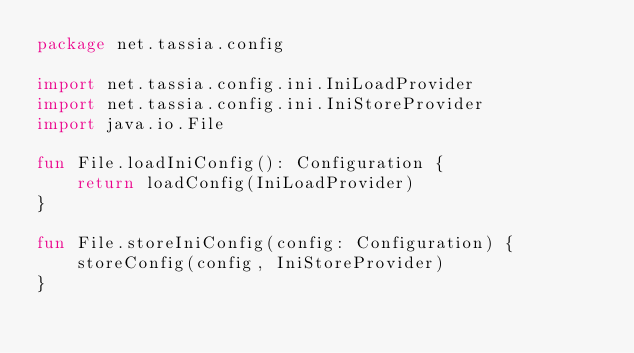<code> <loc_0><loc_0><loc_500><loc_500><_Kotlin_>package net.tassia.config

import net.tassia.config.ini.IniLoadProvider
import net.tassia.config.ini.IniStoreProvider
import java.io.File

fun File.loadIniConfig(): Configuration {
	return loadConfig(IniLoadProvider)
}

fun File.storeIniConfig(config: Configuration) {
	storeConfig(config, IniStoreProvider)
}
</code> 